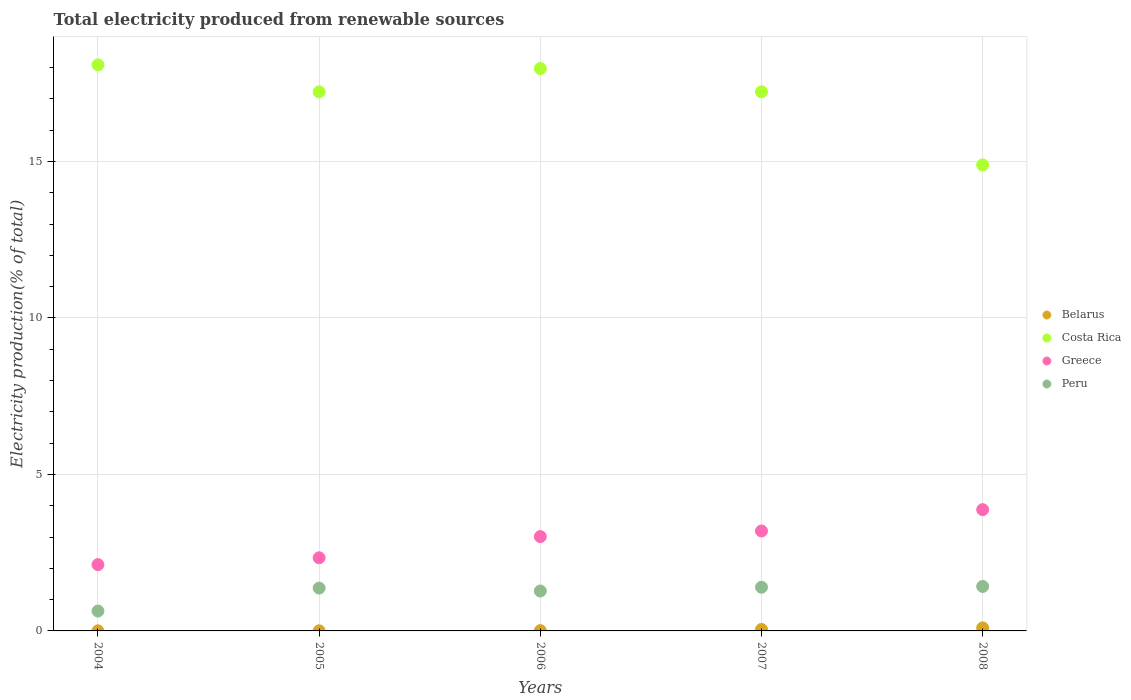How many different coloured dotlines are there?
Give a very brief answer. 4. What is the total electricity produced in Greece in 2004?
Make the answer very short. 2.12. Across all years, what is the maximum total electricity produced in Peru?
Ensure brevity in your answer.  1.42. Across all years, what is the minimum total electricity produced in Peru?
Offer a terse response. 0.63. In which year was the total electricity produced in Greece maximum?
Give a very brief answer. 2008. What is the total total electricity produced in Belarus in the graph?
Your answer should be very brief. 0.16. What is the difference between the total electricity produced in Belarus in 2004 and that in 2006?
Your answer should be compact. -0.01. What is the difference between the total electricity produced in Greece in 2005 and the total electricity produced in Costa Rica in 2007?
Your answer should be very brief. -14.89. What is the average total electricity produced in Greece per year?
Your answer should be compact. 2.91. In the year 2005, what is the difference between the total electricity produced in Greece and total electricity produced in Costa Rica?
Keep it short and to the point. -14.89. What is the ratio of the total electricity produced in Costa Rica in 2006 to that in 2007?
Your response must be concise. 1.04. Is the total electricity produced in Costa Rica in 2004 less than that in 2007?
Make the answer very short. No. What is the difference between the highest and the second highest total electricity produced in Costa Rica?
Ensure brevity in your answer.  0.12. What is the difference between the highest and the lowest total electricity produced in Belarus?
Offer a very short reply. 0.09. In how many years, is the total electricity produced in Costa Rica greater than the average total electricity produced in Costa Rica taken over all years?
Your answer should be very brief. 4. Is the sum of the total electricity produced in Costa Rica in 2005 and 2008 greater than the maximum total electricity produced in Belarus across all years?
Your answer should be compact. Yes. Does the total electricity produced in Peru monotonically increase over the years?
Give a very brief answer. No. Are the values on the major ticks of Y-axis written in scientific E-notation?
Your response must be concise. No. Where does the legend appear in the graph?
Your answer should be compact. Center right. How many legend labels are there?
Keep it short and to the point. 4. How are the legend labels stacked?
Provide a short and direct response. Vertical. What is the title of the graph?
Keep it short and to the point. Total electricity produced from renewable sources. What is the label or title of the X-axis?
Provide a short and direct response. Years. What is the label or title of the Y-axis?
Offer a very short reply. Electricity production(% of total). What is the Electricity production(% of total) of Belarus in 2004?
Your response must be concise. 0. What is the Electricity production(% of total) in Costa Rica in 2004?
Provide a short and direct response. 18.09. What is the Electricity production(% of total) of Greece in 2004?
Your answer should be very brief. 2.12. What is the Electricity production(% of total) of Peru in 2004?
Offer a very short reply. 0.63. What is the Electricity production(% of total) of Belarus in 2005?
Provide a succinct answer. 0. What is the Electricity production(% of total) of Costa Rica in 2005?
Provide a short and direct response. 17.23. What is the Electricity production(% of total) of Greece in 2005?
Provide a short and direct response. 2.34. What is the Electricity production(% of total) of Peru in 2005?
Offer a terse response. 1.37. What is the Electricity production(% of total) in Belarus in 2006?
Ensure brevity in your answer.  0.01. What is the Electricity production(% of total) of Costa Rica in 2006?
Your answer should be very brief. 17.97. What is the Electricity production(% of total) of Greece in 2006?
Your answer should be very brief. 3.01. What is the Electricity production(% of total) in Peru in 2006?
Offer a terse response. 1.28. What is the Electricity production(% of total) of Belarus in 2007?
Give a very brief answer. 0.05. What is the Electricity production(% of total) in Costa Rica in 2007?
Give a very brief answer. 17.23. What is the Electricity production(% of total) in Greece in 2007?
Make the answer very short. 3.19. What is the Electricity production(% of total) of Peru in 2007?
Provide a succinct answer. 1.4. What is the Electricity production(% of total) of Belarus in 2008?
Offer a terse response. 0.1. What is the Electricity production(% of total) of Costa Rica in 2008?
Ensure brevity in your answer.  14.89. What is the Electricity production(% of total) of Greece in 2008?
Offer a very short reply. 3.88. What is the Electricity production(% of total) in Peru in 2008?
Keep it short and to the point. 1.42. Across all years, what is the maximum Electricity production(% of total) in Belarus?
Give a very brief answer. 0.1. Across all years, what is the maximum Electricity production(% of total) of Costa Rica?
Offer a very short reply. 18.09. Across all years, what is the maximum Electricity production(% of total) in Greece?
Your answer should be compact. 3.88. Across all years, what is the maximum Electricity production(% of total) of Peru?
Offer a terse response. 1.42. Across all years, what is the minimum Electricity production(% of total) of Belarus?
Provide a short and direct response. 0. Across all years, what is the minimum Electricity production(% of total) in Costa Rica?
Offer a terse response. 14.89. Across all years, what is the minimum Electricity production(% of total) of Greece?
Offer a terse response. 2.12. Across all years, what is the minimum Electricity production(% of total) in Peru?
Offer a terse response. 0.63. What is the total Electricity production(% of total) of Belarus in the graph?
Provide a short and direct response. 0.16. What is the total Electricity production(% of total) of Costa Rica in the graph?
Your answer should be compact. 85.41. What is the total Electricity production(% of total) of Greece in the graph?
Give a very brief answer. 14.54. What is the total Electricity production(% of total) of Peru in the graph?
Provide a short and direct response. 6.1. What is the difference between the Electricity production(% of total) of Costa Rica in 2004 and that in 2005?
Keep it short and to the point. 0.86. What is the difference between the Electricity production(% of total) in Greece in 2004 and that in 2005?
Your answer should be very brief. -0.22. What is the difference between the Electricity production(% of total) of Peru in 2004 and that in 2005?
Give a very brief answer. -0.73. What is the difference between the Electricity production(% of total) of Belarus in 2004 and that in 2006?
Give a very brief answer. -0.01. What is the difference between the Electricity production(% of total) in Costa Rica in 2004 and that in 2006?
Keep it short and to the point. 0.12. What is the difference between the Electricity production(% of total) of Greece in 2004 and that in 2006?
Provide a succinct answer. -0.9. What is the difference between the Electricity production(% of total) in Peru in 2004 and that in 2006?
Ensure brevity in your answer.  -0.64. What is the difference between the Electricity production(% of total) in Belarus in 2004 and that in 2007?
Provide a short and direct response. -0.04. What is the difference between the Electricity production(% of total) of Costa Rica in 2004 and that in 2007?
Provide a short and direct response. 0.86. What is the difference between the Electricity production(% of total) of Greece in 2004 and that in 2007?
Give a very brief answer. -1.08. What is the difference between the Electricity production(% of total) of Peru in 2004 and that in 2007?
Provide a short and direct response. -0.76. What is the difference between the Electricity production(% of total) in Belarus in 2004 and that in 2008?
Make the answer very short. -0.09. What is the difference between the Electricity production(% of total) of Costa Rica in 2004 and that in 2008?
Your answer should be compact. 3.2. What is the difference between the Electricity production(% of total) of Greece in 2004 and that in 2008?
Offer a very short reply. -1.76. What is the difference between the Electricity production(% of total) of Peru in 2004 and that in 2008?
Offer a terse response. -0.79. What is the difference between the Electricity production(% of total) in Belarus in 2005 and that in 2006?
Your answer should be very brief. -0.01. What is the difference between the Electricity production(% of total) in Costa Rica in 2005 and that in 2006?
Your answer should be very brief. -0.74. What is the difference between the Electricity production(% of total) of Greece in 2005 and that in 2006?
Your answer should be very brief. -0.68. What is the difference between the Electricity production(% of total) in Peru in 2005 and that in 2006?
Offer a very short reply. 0.09. What is the difference between the Electricity production(% of total) of Belarus in 2005 and that in 2007?
Ensure brevity in your answer.  -0.04. What is the difference between the Electricity production(% of total) in Costa Rica in 2005 and that in 2007?
Your answer should be very brief. 0. What is the difference between the Electricity production(% of total) in Greece in 2005 and that in 2007?
Provide a short and direct response. -0.86. What is the difference between the Electricity production(% of total) of Peru in 2005 and that in 2007?
Your response must be concise. -0.03. What is the difference between the Electricity production(% of total) in Belarus in 2005 and that in 2008?
Your answer should be compact. -0.09. What is the difference between the Electricity production(% of total) of Costa Rica in 2005 and that in 2008?
Your answer should be compact. 2.34. What is the difference between the Electricity production(% of total) in Greece in 2005 and that in 2008?
Your response must be concise. -1.54. What is the difference between the Electricity production(% of total) of Peru in 2005 and that in 2008?
Keep it short and to the point. -0.05. What is the difference between the Electricity production(% of total) in Belarus in 2006 and that in 2007?
Your answer should be very brief. -0.04. What is the difference between the Electricity production(% of total) in Costa Rica in 2006 and that in 2007?
Your answer should be very brief. 0.75. What is the difference between the Electricity production(% of total) of Greece in 2006 and that in 2007?
Give a very brief answer. -0.18. What is the difference between the Electricity production(% of total) in Peru in 2006 and that in 2007?
Offer a terse response. -0.12. What is the difference between the Electricity production(% of total) in Belarus in 2006 and that in 2008?
Provide a succinct answer. -0.09. What is the difference between the Electricity production(% of total) in Costa Rica in 2006 and that in 2008?
Give a very brief answer. 3.08. What is the difference between the Electricity production(% of total) of Greece in 2006 and that in 2008?
Ensure brevity in your answer.  -0.86. What is the difference between the Electricity production(% of total) in Peru in 2006 and that in 2008?
Provide a succinct answer. -0.15. What is the difference between the Electricity production(% of total) of Belarus in 2007 and that in 2008?
Make the answer very short. -0.05. What is the difference between the Electricity production(% of total) of Costa Rica in 2007 and that in 2008?
Provide a short and direct response. 2.33. What is the difference between the Electricity production(% of total) in Greece in 2007 and that in 2008?
Give a very brief answer. -0.68. What is the difference between the Electricity production(% of total) in Peru in 2007 and that in 2008?
Provide a succinct answer. -0.03. What is the difference between the Electricity production(% of total) in Belarus in 2004 and the Electricity production(% of total) in Costa Rica in 2005?
Your answer should be very brief. -17.22. What is the difference between the Electricity production(% of total) of Belarus in 2004 and the Electricity production(% of total) of Greece in 2005?
Provide a short and direct response. -2.33. What is the difference between the Electricity production(% of total) of Belarus in 2004 and the Electricity production(% of total) of Peru in 2005?
Offer a terse response. -1.37. What is the difference between the Electricity production(% of total) of Costa Rica in 2004 and the Electricity production(% of total) of Greece in 2005?
Make the answer very short. 15.75. What is the difference between the Electricity production(% of total) in Costa Rica in 2004 and the Electricity production(% of total) in Peru in 2005?
Offer a terse response. 16.72. What is the difference between the Electricity production(% of total) of Greece in 2004 and the Electricity production(% of total) of Peru in 2005?
Give a very brief answer. 0.75. What is the difference between the Electricity production(% of total) in Belarus in 2004 and the Electricity production(% of total) in Costa Rica in 2006?
Keep it short and to the point. -17.97. What is the difference between the Electricity production(% of total) of Belarus in 2004 and the Electricity production(% of total) of Greece in 2006?
Provide a succinct answer. -3.01. What is the difference between the Electricity production(% of total) of Belarus in 2004 and the Electricity production(% of total) of Peru in 2006?
Your response must be concise. -1.27. What is the difference between the Electricity production(% of total) of Costa Rica in 2004 and the Electricity production(% of total) of Greece in 2006?
Provide a short and direct response. 15.07. What is the difference between the Electricity production(% of total) in Costa Rica in 2004 and the Electricity production(% of total) in Peru in 2006?
Make the answer very short. 16.81. What is the difference between the Electricity production(% of total) of Greece in 2004 and the Electricity production(% of total) of Peru in 2006?
Your answer should be compact. 0.84. What is the difference between the Electricity production(% of total) in Belarus in 2004 and the Electricity production(% of total) in Costa Rica in 2007?
Provide a succinct answer. -17.22. What is the difference between the Electricity production(% of total) of Belarus in 2004 and the Electricity production(% of total) of Greece in 2007?
Provide a succinct answer. -3.19. What is the difference between the Electricity production(% of total) in Belarus in 2004 and the Electricity production(% of total) in Peru in 2007?
Provide a succinct answer. -1.39. What is the difference between the Electricity production(% of total) in Costa Rica in 2004 and the Electricity production(% of total) in Greece in 2007?
Provide a short and direct response. 14.89. What is the difference between the Electricity production(% of total) of Costa Rica in 2004 and the Electricity production(% of total) of Peru in 2007?
Make the answer very short. 16.69. What is the difference between the Electricity production(% of total) in Greece in 2004 and the Electricity production(% of total) in Peru in 2007?
Make the answer very short. 0.72. What is the difference between the Electricity production(% of total) of Belarus in 2004 and the Electricity production(% of total) of Costa Rica in 2008?
Offer a terse response. -14.89. What is the difference between the Electricity production(% of total) in Belarus in 2004 and the Electricity production(% of total) in Greece in 2008?
Your answer should be compact. -3.87. What is the difference between the Electricity production(% of total) in Belarus in 2004 and the Electricity production(% of total) in Peru in 2008?
Ensure brevity in your answer.  -1.42. What is the difference between the Electricity production(% of total) of Costa Rica in 2004 and the Electricity production(% of total) of Greece in 2008?
Ensure brevity in your answer.  14.21. What is the difference between the Electricity production(% of total) in Costa Rica in 2004 and the Electricity production(% of total) in Peru in 2008?
Make the answer very short. 16.67. What is the difference between the Electricity production(% of total) in Greece in 2004 and the Electricity production(% of total) in Peru in 2008?
Give a very brief answer. 0.7. What is the difference between the Electricity production(% of total) of Belarus in 2005 and the Electricity production(% of total) of Costa Rica in 2006?
Ensure brevity in your answer.  -17.97. What is the difference between the Electricity production(% of total) of Belarus in 2005 and the Electricity production(% of total) of Greece in 2006?
Ensure brevity in your answer.  -3.01. What is the difference between the Electricity production(% of total) of Belarus in 2005 and the Electricity production(% of total) of Peru in 2006?
Make the answer very short. -1.27. What is the difference between the Electricity production(% of total) in Costa Rica in 2005 and the Electricity production(% of total) in Greece in 2006?
Give a very brief answer. 14.21. What is the difference between the Electricity production(% of total) of Costa Rica in 2005 and the Electricity production(% of total) of Peru in 2006?
Your answer should be compact. 15.95. What is the difference between the Electricity production(% of total) of Greece in 2005 and the Electricity production(% of total) of Peru in 2006?
Make the answer very short. 1.06. What is the difference between the Electricity production(% of total) of Belarus in 2005 and the Electricity production(% of total) of Costa Rica in 2007?
Your response must be concise. -17.22. What is the difference between the Electricity production(% of total) of Belarus in 2005 and the Electricity production(% of total) of Greece in 2007?
Ensure brevity in your answer.  -3.19. What is the difference between the Electricity production(% of total) in Belarus in 2005 and the Electricity production(% of total) in Peru in 2007?
Your answer should be compact. -1.39. What is the difference between the Electricity production(% of total) of Costa Rica in 2005 and the Electricity production(% of total) of Greece in 2007?
Give a very brief answer. 14.03. What is the difference between the Electricity production(% of total) in Costa Rica in 2005 and the Electricity production(% of total) in Peru in 2007?
Make the answer very short. 15.83. What is the difference between the Electricity production(% of total) in Greece in 2005 and the Electricity production(% of total) in Peru in 2007?
Your answer should be very brief. 0.94. What is the difference between the Electricity production(% of total) in Belarus in 2005 and the Electricity production(% of total) in Costa Rica in 2008?
Offer a terse response. -14.89. What is the difference between the Electricity production(% of total) of Belarus in 2005 and the Electricity production(% of total) of Greece in 2008?
Provide a succinct answer. -3.87. What is the difference between the Electricity production(% of total) in Belarus in 2005 and the Electricity production(% of total) in Peru in 2008?
Provide a short and direct response. -1.42. What is the difference between the Electricity production(% of total) in Costa Rica in 2005 and the Electricity production(% of total) in Greece in 2008?
Ensure brevity in your answer.  13.35. What is the difference between the Electricity production(% of total) in Costa Rica in 2005 and the Electricity production(% of total) in Peru in 2008?
Your answer should be very brief. 15.81. What is the difference between the Electricity production(% of total) of Greece in 2005 and the Electricity production(% of total) of Peru in 2008?
Keep it short and to the point. 0.92. What is the difference between the Electricity production(% of total) in Belarus in 2006 and the Electricity production(% of total) in Costa Rica in 2007?
Give a very brief answer. -17.22. What is the difference between the Electricity production(% of total) in Belarus in 2006 and the Electricity production(% of total) in Greece in 2007?
Ensure brevity in your answer.  -3.18. What is the difference between the Electricity production(% of total) of Belarus in 2006 and the Electricity production(% of total) of Peru in 2007?
Provide a short and direct response. -1.39. What is the difference between the Electricity production(% of total) in Costa Rica in 2006 and the Electricity production(% of total) in Greece in 2007?
Your response must be concise. 14.78. What is the difference between the Electricity production(% of total) in Costa Rica in 2006 and the Electricity production(% of total) in Peru in 2007?
Give a very brief answer. 16.58. What is the difference between the Electricity production(% of total) of Greece in 2006 and the Electricity production(% of total) of Peru in 2007?
Provide a short and direct response. 1.62. What is the difference between the Electricity production(% of total) of Belarus in 2006 and the Electricity production(% of total) of Costa Rica in 2008?
Offer a terse response. -14.88. What is the difference between the Electricity production(% of total) in Belarus in 2006 and the Electricity production(% of total) in Greece in 2008?
Ensure brevity in your answer.  -3.87. What is the difference between the Electricity production(% of total) of Belarus in 2006 and the Electricity production(% of total) of Peru in 2008?
Offer a very short reply. -1.41. What is the difference between the Electricity production(% of total) of Costa Rica in 2006 and the Electricity production(% of total) of Greece in 2008?
Give a very brief answer. 14.1. What is the difference between the Electricity production(% of total) in Costa Rica in 2006 and the Electricity production(% of total) in Peru in 2008?
Keep it short and to the point. 16.55. What is the difference between the Electricity production(% of total) of Greece in 2006 and the Electricity production(% of total) of Peru in 2008?
Provide a short and direct response. 1.59. What is the difference between the Electricity production(% of total) of Belarus in 2007 and the Electricity production(% of total) of Costa Rica in 2008?
Your response must be concise. -14.84. What is the difference between the Electricity production(% of total) in Belarus in 2007 and the Electricity production(% of total) in Greece in 2008?
Give a very brief answer. -3.83. What is the difference between the Electricity production(% of total) in Belarus in 2007 and the Electricity production(% of total) in Peru in 2008?
Make the answer very short. -1.37. What is the difference between the Electricity production(% of total) of Costa Rica in 2007 and the Electricity production(% of total) of Greece in 2008?
Your answer should be compact. 13.35. What is the difference between the Electricity production(% of total) of Costa Rica in 2007 and the Electricity production(% of total) of Peru in 2008?
Your answer should be very brief. 15.8. What is the difference between the Electricity production(% of total) in Greece in 2007 and the Electricity production(% of total) in Peru in 2008?
Provide a short and direct response. 1.77. What is the average Electricity production(% of total) in Belarus per year?
Make the answer very short. 0.03. What is the average Electricity production(% of total) in Costa Rica per year?
Your answer should be compact. 17.08. What is the average Electricity production(% of total) of Greece per year?
Give a very brief answer. 2.91. What is the average Electricity production(% of total) of Peru per year?
Your response must be concise. 1.22. In the year 2004, what is the difference between the Electricity production(% of total) in Belarus and Electricity production(% of total) in Costa Rica?
Make the answer very short. -18.09. In the year 2004, what is the difference between the Electricity production(% of total) of Belarus and Electricity production(% of total) of Greece?
Your answer should be very brief. -2.12. In the year 2004, what is the difference between the Electricity production(% of total) of Belarus and Electricity production(% of total) of Peru?
Your answer should be very brief. -0.63. In the year 2004, what is the difference between the Electricity production(% of total) in Costa Rica and Electricity production(% of total) in Greece?
Your answer should be compact. 15.97. In the year 2004, what is the difference between the Electricity production(% of total) in Costa Rica and Electricity production(% of total) in Peru?
Offer a terse response. 17.45. In the year 2004, what is the difference between the Electricity production(% of total) of Greece and Electricity production(% of total) of Peru?
Ensure brevity in your answer.  1.48. In the year 2005, what is the difference between the Electricity production(% of total) of Belarus and Electricity production(% of total) of Costa Rica?
Keep it short and to the point. -17.22. In the year 2005, what is the difference between the Electricity production(% of total) of Belarus and Electricity production(% of total) of Greece?
Your answer should be very brief. -2.33. In the year 2005, what is the difference between the Electricity production(% of total) in Belarus and Electricity production(% of total) in Peru?
Your answer should be very brief. -1.37. In the year 2005, what is the difference between the Electricity production(% of total) in Costa Rica and Electricity production(% of total) in Greece?
Your answer should be compact. 14.89. In the year 2005, what is the difference between the Electricity production(% of total) of Costa Rica and Electricity production(% of total) of Peru?
Provide a succinct answer. 15.86. In the year 2005, what is the difference between the Electricity production(% of total) in Greece and Electricity production(% of total) in Peru?
Provide a short and direct response. 0.97. In the year 2006, what is the difference between the Electricity production(% of total) of Belarus and Electricity production(% of total) of Costa Rica?
Make the answer very short. -17.96. In the year 2006, what is the difference between the Electricity production(% of total) in Belarus and Electricity production(% of total) in Greece?
Ensure brevity in your answer.  -3. In the year 2006, what is the difference between the Electricity production(% of total) in Belarus and Electricity production(% of total) in Peru?
Offer a terse response. -1.27. In the year 2006, what is the difference between the Electricity production(% of total) in Costa Rica and Electricity production(% of total) in Greece?
Provide a short and direct response. 14.96. In the year 2006, what is the difference between the Electricity production(% of total) in Costa Rica and Electricity production(% of total) in Peru?
Ensure brevity in your answer.  16.7. In the year 2006, what is the difference between the Electricity production(% of total) of Greece and Electricity production(% of total) of Peru?
Offer a terse response. 1.74. In the year 2007, what is the difference between the Electricity production(% of total) in Belarus and Electricity production(% of total) in Costa Rica?
Your answer should be compact. -17.18. In the year 2007, what is the difference between the Electricity production(% of total) of Belarus and Electricity production(% of total) of Greece?
Provide a short and direct response. -3.15. In the year 2007, what is the difference between the Electricity production(% of total) of Belarus and Electricity production(% of total) of Peru?
Provide a short and direct response. -1.35. In the year 2007, what is the difference between the Electricity production(% of total) in Costa Rica and Electricity production(% of total) in Greece?
Your answer should be compact. 14.03. In the year 2007, what is the difference between the Electricity production(% of total) in Costa Rica and Electricity production(% of total) in Peru?
Make the answer very short. 15.83. In the year 2007, what is the difference between the Electricity production(% of total) in Greece and Electricity production(% of total) in Peru?
Offer a very short reply. 1.8. In the year 2008, what is the difference between the Electricity production(% of total) of Belarus and Electricity production(% of total) of Costa Rica?
Your response must be concise. -14.79. In the year 2008, what is the difference between the Electricity production(% of total) in Belarus and Electricity production(% of total) in Greece?
Ensure brevity in your answer.  -3.78. In the year 2008, what is the difference between the Electricity production(% of total) of Belarus and Electricity production(% of total) of Peru?
Your answer should be very brief. -1.32. In the year 2008, what is the difference between the Electricity production(% of total) in Costa Rica and Electricity production(% of total) in Greece?
Your answer should be compact. 11.02. In the year 2008, what is the difference between the Electricity production(% of total) in Costa Rica and Electricity production(% of total) in Peru?
Ensure brevity in your answer.  13.47. In the year 2008, what is the difference between the Electricity production(% of total) of Greece and Electricity production(% of total) of Peru?
Make the answer very short. 2.45. What is the ratio of the Electricity production(% of total) of Greece in 2004 to that in 2005?
Your answer should be compact. 0.91. What is the ratio of the Electricity production(% of total) of Peru in 2004 to that in 2005?
Ensure brevity in your answer.  0.46. What is the ratio of the Electricity production(% of total) in Belarus in 2004 to that in 2006?
Your response must be concise. 0.34. What is the ratio of the Electricity production(% of total) of Costa Rica in 2004 to that in 2006?
Offer a very short reply. 1.01. What is the ratio of the Electricity production(% of total) in Greece in 2004 to that in 2006?
Offer a very short reply. 0.7. What is the ratio of the Electricity production(% of total) in Peru in 2004 to that in 2006?
Give a very brief answer. 0.5. What is the ratio of the Electricity production(% of total) in Belarus in 2004 to that in 2007?
Ensure brevity in your answer.  0.07. What is the ratio of the Electricity production(% of total) in Costa Rica in 2004 to that in 2007?
Ensure brevity in your answer.  1.05. What is the ratio of the Electricity production(% of total) in Greece in 2004 to that in 2007?
Your answer should be very brief. 0.66. What is the ratio of the Electricity production(% of total) of Peru in 2004 to that in 2007?
Your answer should be very brief. 0.45. What is the ratio of the Electricity production(% of total) in Belarus in 2004 to that in 2008?
Make the answer very short. 0.03. What is the ratio of the Electricity production(% of total) in Costa Rica in 2004 to that in 2008?
Your answer should be very brief. 1.21. What is the ratio of the Electricity production(% of total) in Greece in 2004 to that in 2008?
Ensure brevity in your answer.  0.55. What is the ratio of the Electricity production(% of total) of Peru in 2004 to that in 2008?
Provide a succinct answer. 0.45. What is the ratio of the Electricity production(% of total) in Belarus in 2005 to that in 2006?
Provide a short and direct response. 0.34. What is the ratio of the Electricity production(% of total) in Costa Rica in 2005 to that in 2006?
Your answer should be very brief. 0.96. What is the ratio of the Electricity production(% of total) in Greece in 2005 to that in 2006?
Provide a short and direct response. 0.78. What is the ratio of the Electricity production(% of total) of Peru in 2005 to that in 2006?
Provide a succinct answer. 1.07. What is the ratio of the Electricity production(% of total) of Belarus in 2005 to that in 2007?
Keep it short and to the point. 0.07. What is the ratio of the Electricity production(% of total) of Greece in 2005 to that in 2007?
Keep it short and to the point. 0.73. What is the ratio of the Electricity production(% of total) in Belarus in 2005 to that in 2008?
Offer a terse response. 0.03. What is the ratio of the Electricity production(% of total) in Costa Rica in 2005 to that in 2008?
Offer a terse response. 1.16. What is the ratio of the Electricity production(% of total) in Greece in 2005 to that in 2008?
Provide a succinct answer. 0.6. What is the ratio of the Electricity production(% of total) in Peru in 2005 to that in 2008?
Offer a very short reply. 0.96. What is the ratio of the Electricity production(% of total) of Belarus in 2006 to that in 2007?
Offer a very short reply. 0.2. What is the ratio of the Electricity production(% of total) of Costa Rica in 2006 to that in 2007?
Your response must be concise. 1.04. What is the ratio of the Electricity production(% of total) in Greece in 2006 to that in 2007?
Offer a terse response. 0.94. What is the ratio of the Electricity production(% of total) in Peru in 2006 to that in 2007?
Ensure brevity in your answer.  0.91. What is the ratio of the Electricity production(% of total) in Belarus in 2006 to that in 2008?
Give a very brief answer. 0.1. What is the ratio of the Electricity production(% of total) in Costa Rica in 2006 to that in 2008?
Provide a short and direct response. 1.21. What is the ratio of the Electricity production(% of total) of Greece in 2006 to that in 2008?
Give a very brief answer. 0.78. What is the ratio of the Electricity production(% of total) in Peru in 2006 to that in 2008?
Provide a short and direct response. 0.9. What is the ratio of the Electricity production(% of total) of Belarus in 2007 to that in 2008?
Keep it short and to the point. 0.49. What is the ratio of the Electricity production(% of total) in Costa Rica in 2007 to that in 2008?
Give a very brief answer. 1.16. What is the ratio of the Electricity production(% of total) in Greece in 2007 to that in 2008?
Give a very brief answer. 0.82. What is the ratio of the Electricity production(% of total) of Peru in 2007 to that in 2008?
Provide a short and direct response. 0.98. What is the difference between the highest and the second highest Electricity production(% of total) of Belarus?
Your answer should be compact. 0.05. What is the difference between the highest and the second highest Electricity production(% of total) in Costa Rica?
Your answer should be compact. 0.12. What is the difference between the highest and the second highest Electricity production(% of total) of Greece?
Your answer should be very brief. 0.68. What is the difference between the highest and the second highest Electricity production(% of total) of Peru?
Keep it short and to the point. 0.03. What is the difference between the highest and the lowest Electricity production(% of total) in Belarus?
Your response must be concise. 0.09. What is the difference between the highest and the lowest Electricity production(% of total) of Costa Rica?
Your answer should be compact. 3.2. What is the difference between the highest and the lowest Electricity production(% of total) of Greece?
Offer a very short reply. 1.76. What is the difference between the highest and the lowest Electricity production(% of total) of Peru?
Offer a very short reply. 0.79. 